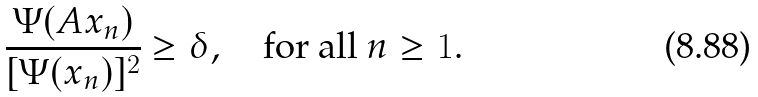<formula> <loc_0><loc_0><loc_500><loc_500>\frac { \Psi ( A x _ { n } ) } { [ \Psi ( x _ { n } ) ] ^ { 2 } } \geq \delta , \quad \text {for all } n \geq 1 .</formula> 